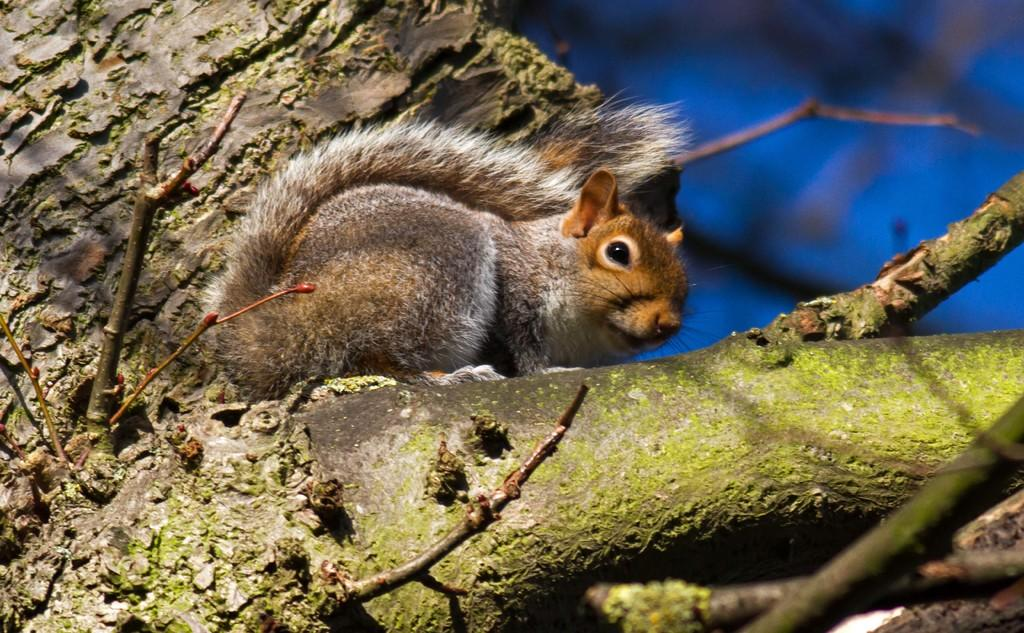What is present on the tree branch in the image? There is a squirrel sitting on the tree branch in the image. What is the condition of the tree branch? The tree branch has mold on it. Can you describe the squirrel's position on the tree branch? The squirrel is sitting on the tree branch. Is there a chair visible in the image? No, there is no chair present in the image. Is there any smoke coming from the squirrel in the image? No, there is no smoke present in the image. 